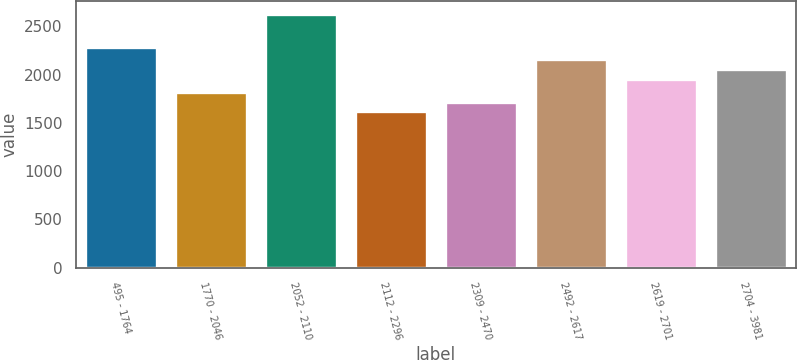Convert chart. <chart><loc_0><loc_0><loc_500><loc_500><bar_chart><fcel>495 - 1764<fcel>1770 - 2046<fcel>2052 - 2110<fcel>2112 - 2296<fcel>2309 - 2470<fcel>2492 - 2617<fcel>2619 - 2701<fcel>2704 - 3981<nl><fcel>2285<fcel>1821.8<fcel>2629<fcel>1620<fcel>1720.9<fcel>2160.8<fcel>1959<fcel>2059.9<nl></chart> 